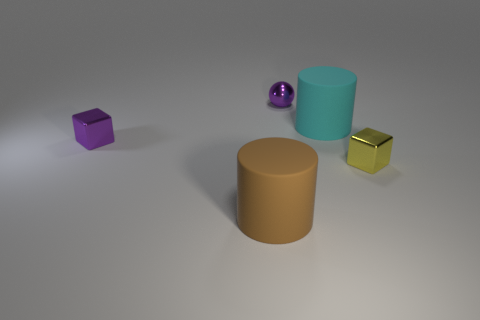Subtract 1 cylinders. How many cylinders are left? 1 Subtract all cubes. How many objects are left? 3 Subtract all brown spheres. How many red cylinders are left? 0 Subtract all green balls. Subtract all red cylinders. How many balls are left? 1 Add 1 brown cylinders. How many brown cylinders exist? 2 Add 2 small purple things. How many objects exist? 7 Subtract 1 cyan cylinders. How many objects are left? 4 Subtract all small red shiny blocks. Subtract all brown things. How many objects are left? 4 Add 4 yellow cubes. How many yellow cubes are left? 5 